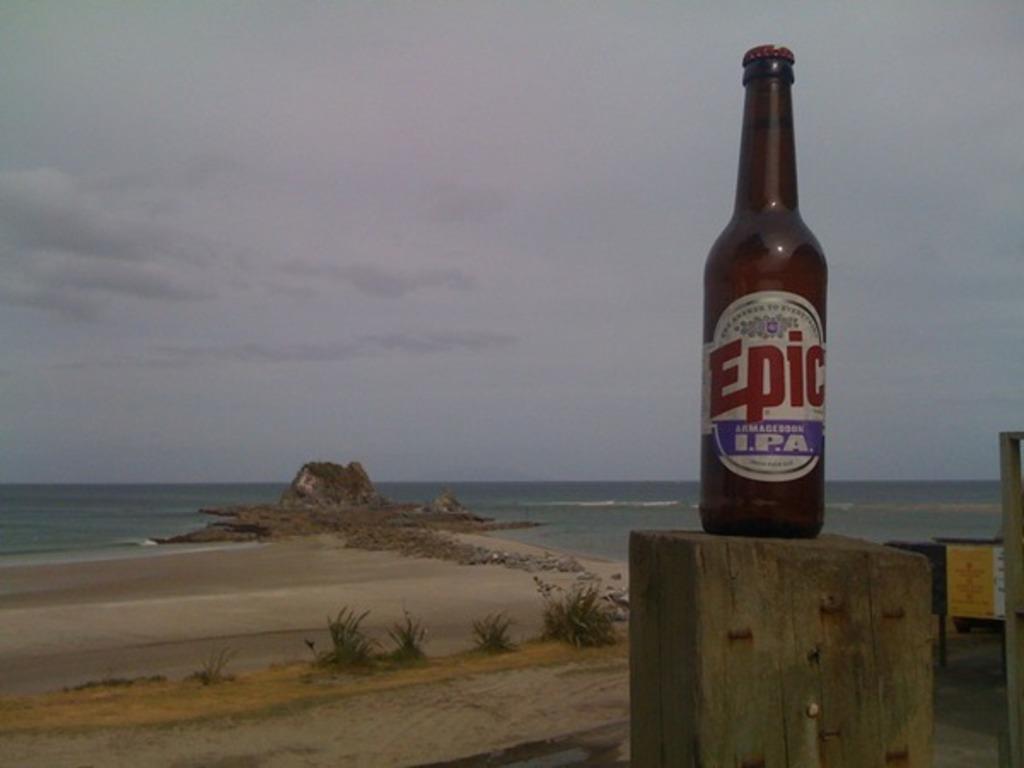Is this an ipa?
Provide a short and direct response. Yes. 